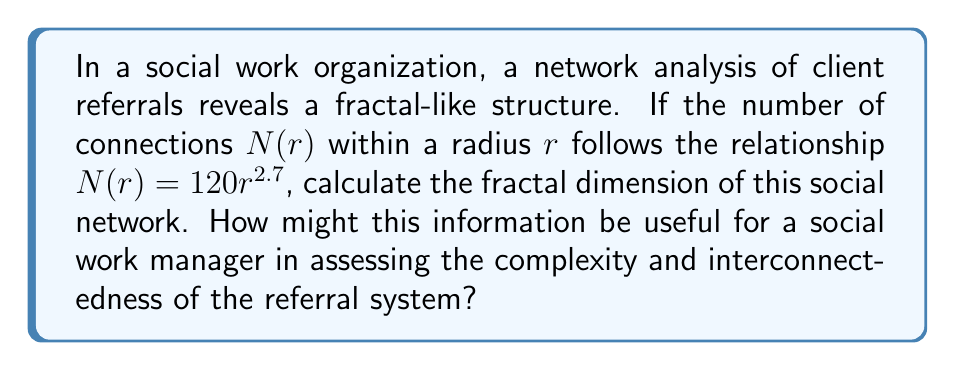Help me with this question. To calculate the fractal dimension of the social network, we'll follow these steps:

1) The general form of the relationship between $N(r)$ and $r$ for a fractal is:

   $$N(r) = kr^D$$

   where $k$ is a constant and $D$ is the fractal dimension.

2) In our case, we have:

   $$N(r) = 120r^{2.7}$$

3) Comparing this to the general form, we can see that:

   $k = 120$
   $D = 2.7$

4) Therefore, the fractal dimension of the social network is 2.7.

5) Interpretation for a social work manager:
   - A fractal dimension between 2 and 3 indicates a highly complex and interconnected network.
   - The value of 2.7 suggests that the referral system is more complex than a simple 2D structure but not quite as complex as a fully 3D structure.
   - This high level of complexity might indicate:
     a) A diverse range of services and referral pathways
     b) Potential for efficient information flow, but also risk of overwhelming complexity
     c) Need for robust management systems to handle the intricate referral processes
   - The manager might use this information to:
     a) Assess the need for additional coordination resources
     b) Identify potential bottlenecks or critical nodes in the referral system
     c) Develop strategies to optimize the network's efficiency while maintaining ethical standards
Answer: 2.7 